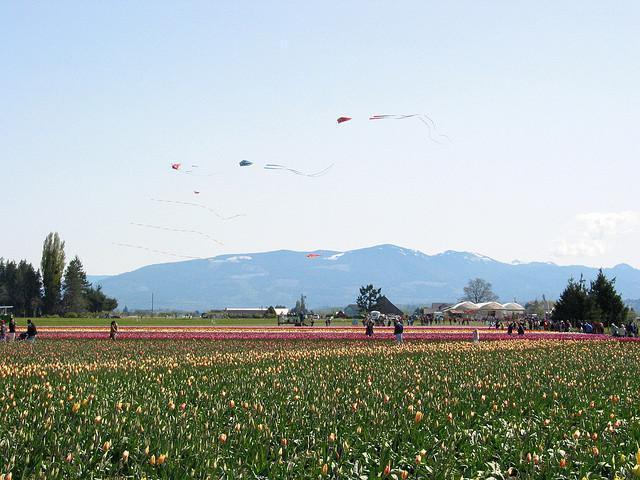How many zebra are in the picture?
Give a very brief answer. 0. 